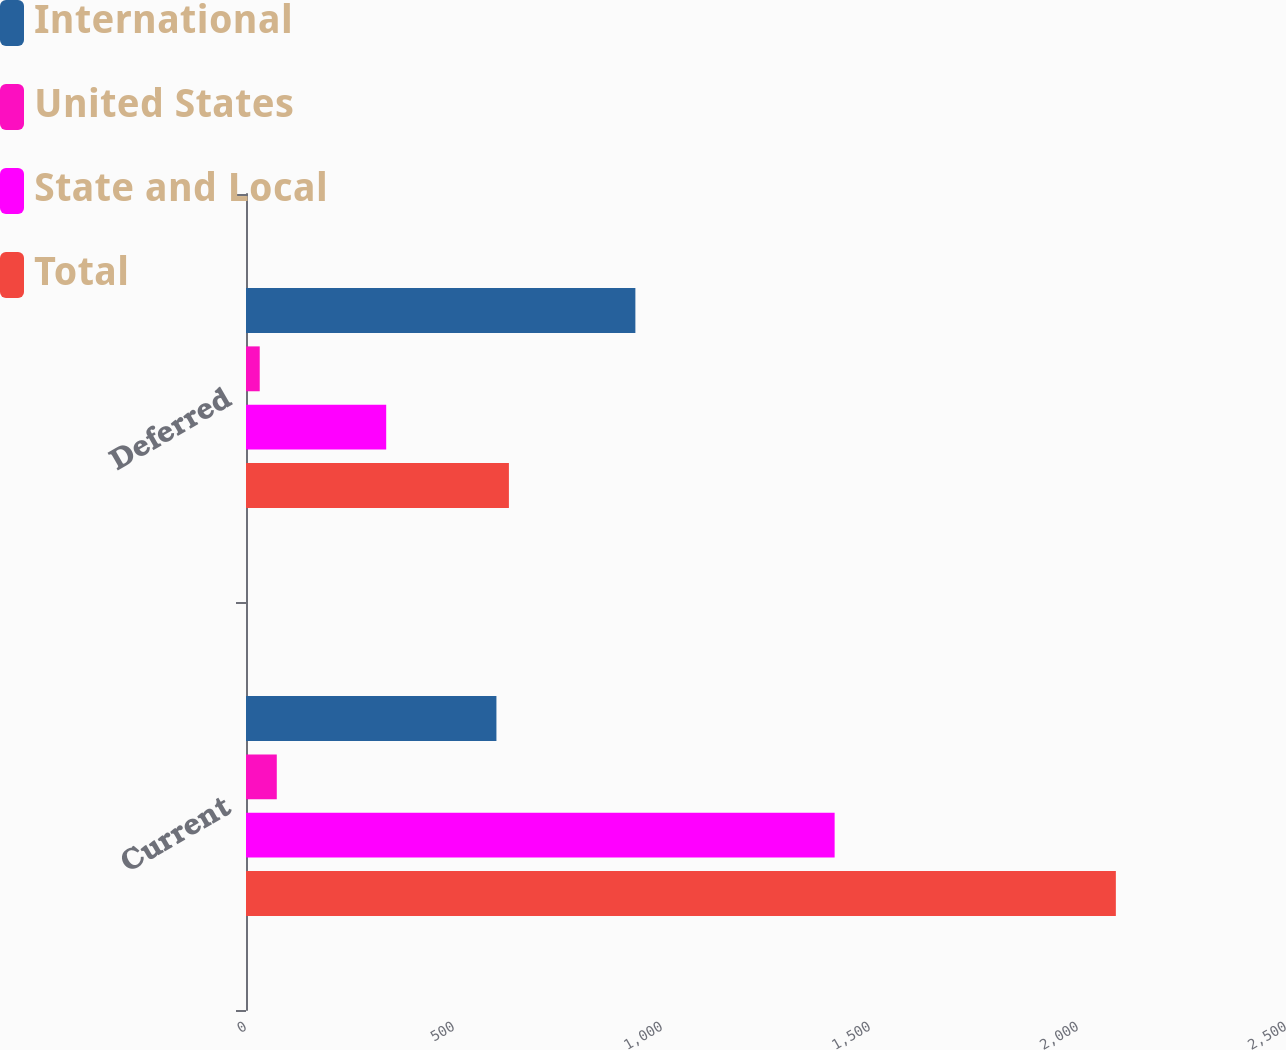Convert chart. <chart><loc_0><loc_0><loc_500><loc_500><stacked_bar_chart><ecel><fcel>Current<fcel>Deferred<nl><fcel>International<fcel>602<fcel>936<nl><fcel>United States<fcel>74<fcel>33<nl><fcel>State and Local<fcel>1415<fcel>337<nl><fcel>Total<fcel>2091<fcel>632<nl></chart> 